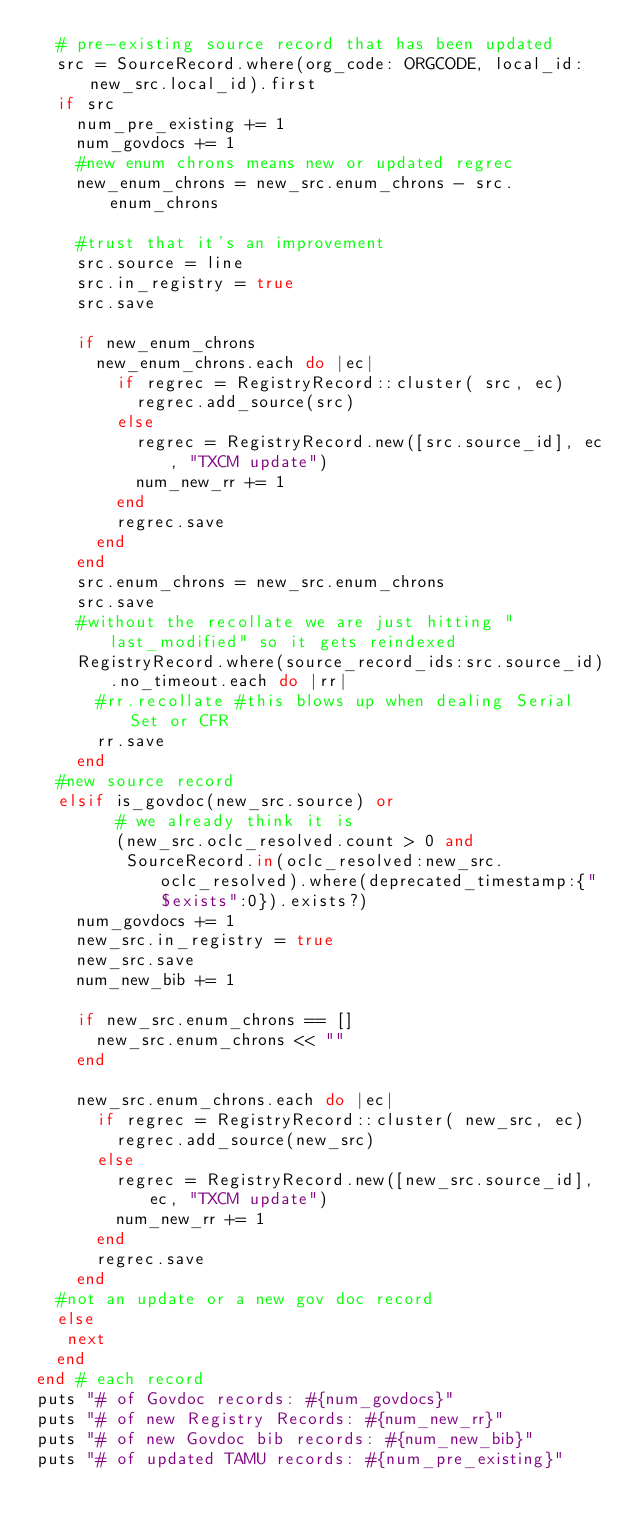<code> <loc_0><loc_0><loc_500><loc_500><_Ruby_>  # pre-existing source record that has been updated
  src = SourceRecord.where(org_code: ORGCODE, local_id: new_src.local_id).first
  if src
    num_pre_existing += 1
    num_govdocs += 1
    #new enum chrons means new or updated regrec
    new_enum_chrons = new_src.enum_chrons - src.enum_chrons

    #trust that it's an improvement
    src.source = line
    src.in_registry = true
    src.save
    
    if new_enum_chrons 
      new_enum_chrons.each do |ec| 
        if regrec = RegistryRecord::cluster( src, ec)
          regrec.add_source(src)
        else
          regrec = RegistryRecord.new([src.source_id], ec, "TXCM update")
          num_new_rr += 1
        end
        regrec.save
      end
    end
    src.enum_chrons = new_src.enum_chrons
    src.save
    #without the recollate we are just hitting "last_modified" so it gets reindexed
    RegistryRecord.where(source_record_ids:src.source_id).no_timeout.each do |rr| 
      #rr.recollate #this blows up when dealing Serial Set or CFR
      rr.save
    end
  #new source record
  elsif is_govdoc(new_src.source) or 
        # we already think it is
        (new_src.oclc_resolved.count > 0 and 
         SourceRecord.in(oclc_resolved:new_src.oclc_resolved).where(deprecated_timestamp:{"$exists":0}).exists?)
    num_govdocs += 1
    new_src.in_registry = true
    new_src.save
    num_new_bib += 1

    if new_src.enum_chrons == []
      new_src.enum_chrons << ""
    end

    new_src.enum_chrons.each do |ec| 
      if regrec = RegistryRecord::cluster( new_src, ec)
        regrec.add_source(new_src)
      else
        regrec = RegistryRecord.new([new_src.source_id], ec, "TXCM update")
        num_new_rr += 1
      end
      regrec.save
    end
  #not an update or a new gov doc record
  else
   next
  end 
end # each record
puts "# of Govdoc records: #{num_govdocs}"
puts "# of new Registry Records: #{num_new_rr}"
puts "# of new Govdoc bib records: #{num_new_bib}"
puts "# of updated TAMU records: #{num_pre_existing}"

</code> 